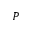Convert formula to latex. <formula><loc_0><loc_0><loc_500><loc_500>P</formula> 